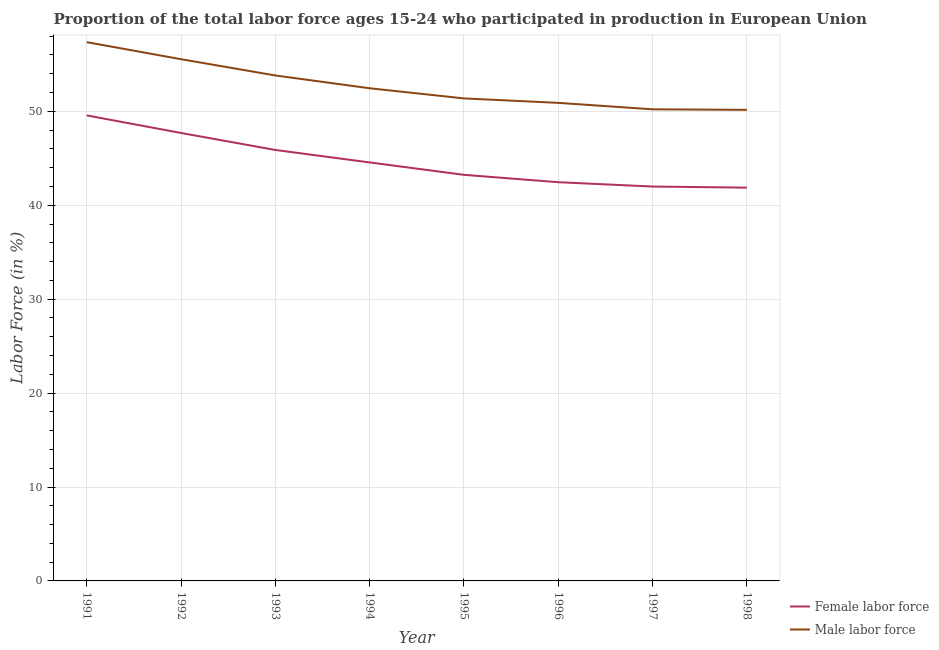How many different coloured lines are there?
Provide a succinct answer. 2. Is the number of lines equal to the number of legend labels?
Ensure brevity in your answer.  Yes. What is the percentage of female labor force in 1994?
Keep it short and to the point. 44.56. Across all years, what is the maximum percentage of female labor force?
Your answer should be compact. 49.57. Across all years, what is the minimum percentage of female labor force?
Give a very brief answer. 41.87. What is the total percentage of male labour force in the graph?
Offer a terse response. 421.84. What is the difference between the percentage of female labor force in 1992 and that in 1998?
Your answer should be compact. 5.82. What is the difference between the percentage of male labour force in 1996 and the percentage of female labor force in 1993?
Keep it short and to the point. 5.02. What is the average percentage of female labor force per year?
Keep it short and to the point. 44.66. In the year 1997, what is the difference between the percentage of female labor force and percentage of male labour force?
Keep it short and to the point. -8.22. In how many years, is the percentage of female labor force greater than 54 %?
Your answer should be very brief. 0. What is the ratio of the percentage of female labor force in 1993 to that in 1996?
Offer a terse response. 1.08. Is the difference between the percentage of female labor force in 1991 and 1993 greater than the difference between the percentage of male labour force in 1991 and 1993?
Ensure brevity in your answer.  Yes. What is the difference between the highest and the second highest percentage of female labor force?
Provide a short and direct response. 1.87. What is the difference between the highest and the lowest percentage of male labour force?
Offer a terse response. 7.21. In how many years, is the percentage of female labor force greater than the average percentage of female labor force taken over all years?
Your response must be concise. 3. Does the percentage of male labour force monotonically increase over the years?
Make the answer very short. No. Is the percentage of male labour force strictly greater than the percentage of female labor force over the years?
Your answer should be compact. Yes. Is the percentage of male labour force strictly less than the percentage of female labor force over the years?
Offer a terse response. No. How many lines are there?
Provide a succinct answer. 2. Are the values on the major ticks of Y-axis written in scientific E-notation?
Your answer should be compact. No. Where does the legend appear in the graph?
Your answer should be compact. Bottom right. How are the legend labels stacked?
Your response must be concise. Vertical. What is the title of the graph?
Ensure brevity in your answer.  Proportion of the total labor force ages 15-24 who participated in production in European Union. What is the Labor Force (in %) in Female labor force in 1991?
Ensure brevity in your answer.  49.57. What is the Labor Force (in %) in Male labor force in 1991?
Your answer should be compact. 57.37. What is the Labor Force (in %) of Female labor force in 1992?
Make the answer very short. 47.7. What is the Labor Force (in %) of Male labor force in 1992?
Provide a short and direct response. 55.55. What is the Labor Force (in %) of Female labor force in 1993?
Your answer should be very brief. 45.89. What is the Labor Force (in %) in Male labor force in 1993?
Offer a very short reply. 53.82. What is the Labor Force (in %) of Female labor force in 1994?
Your answer should be very brief. 44.56. What is the Labor Force (in %) in Male labor force in 1994?
Offer a very short reply. 52.46. What is the Labor Force (in %) of Female labor force in 1995?
Offer a terse response. 43.24. What is the Labor Force (in %) of Male labor force in 1995?
Provide a succinct answer. 51.38. What is the Labor Force (in %) of Female labor force in 1996?
Your answer should be very brief. 42.45. What is the Labor Force (in %) in Male labor force in 1996?
Make the answer very short. 50.9. What is the Labor Force (in %) in Female labor force in 1997?
Offer a terse response. 41.99. What is the Labor Force (in %) in Male labor force in 1997?
Your response must be concise. 50.21. What is the Labor Force (in %) of Female labor force in 1998?
Make the answer very short. 41.87. What is the Labor Force (in %) of Male labor force in 1998?
Your response must be concise. 50.16. Across all years, what is the maximum Labor Force (in %) in Female labor force?
Your response must be concise. 49.57. Across all years, what is the maximum Labor Force (in %) of Male labor force?
Give a very brief answer. 57.37. Across all years, what is the minimum Labor Force (in %) of Female labor force?
Provide a succinct answer. 41.87. Across all years, what is the minimum Labor Force (in %) of Male labor force?
Give a very brief answer. 50.16. What is the total Labor Force (in %) of Female labor force in the graph?
Your response must be concise. 357.26. What is the total Labor Force (in %) in Male labor force in the graph?
Your response must be concise. 421.84. What is the difference between the Labor Force (in %) in Female labor force in 1991 and that in 1992?
Your response must be concise. 1.87. What is the difference between the Labor Force (in %) of Male labor force in 1991 and that in 1992?
Provide a short and direct response. 1.82. What is the difference between the Labor Force (in %) in Female labor force in 1991 and that in 1993?
Your answer should be compact. 3.68. What is the difference between the Labor Force (in %) in Male labor force in 1991 and that in 1993?
Keep it short and to the point. 3.55. What is the difference between the Labor Force (in %) in Female labor force in 1991 and that in 1994?
Provide a succinct answer. 5.01. What is the difference between the Labor Force (in %) in Male labor force in 1991 and that in 1994?
Offer a terse response. 4.91. What is the difference between the Labor Force (in %) in Female labor force in 1991 and that in 1995?
Your answer should be compact. 6.33. What is the difference between the Labor Force (in %) of Male labor force in 1991 and that in 1995?
Provide a short and direct response. 5.99. What is the difference between the Labor Force (in %) of Female labor force in 1991 and that in 1996?
Your answer should be very brief. 7.11. What is the difference between the Labor Force (in %) in Male labor force in 1991 and that in 1996?
Provide a short and direct response. 6.46. What is the difference between the Labor Force (in %) in Female labor force in 1991 and that in 1997?
Your answer should be very brief. 7.58. What is the difference between the Labor Force (in %) of Male labor force in 1991 and that in 1997?
Offer a very short reply. 7.15. What is the difference between the Labor Force (in %) of Female labor force in 1991 and that in 1998?
Make the answer very short. 7.69. What is the difference between the Labor Force (in %) in Male labor force in 1991 and that in 1998?
Ensure brevity in your answer.  7.21. What is the difference between the Labor Force (in %) in Female labor force in 1992 and that in 1993?
Keep it short and to the point. 1.81. What is the difference between the Labor Force (in %) in Male labor force in 1992 and that in 1993?
Your response must be concise. 1.73. What is the difference between the Labor Force (in %) of Female labor force in 1992 and that in 1994?
Provide a succinct answer. 3.14. What is the difference between the Labor Force (in %) of Male labor force in 1992 and that in 1994?
Ensure brevity in your answer.  3.09. What is the difference between the Labor Force (in %) of Female labor force in 1992 and that in 1995?
Make the answer very short. 4.46. What is the difference between the Labor Force (in %) of Male labor force in 1992 and that in 1995?
Provide a succinct answer. 4.17. What is the difference between the Labor Force (in %) in Female labor force in 1992 and that in 1996?
Offer a very short reply. 5.24. What is the difference between the Labor Force (in %) of Male labor force in 1992 and that in 1996?
Your response must be concise. 4.65. What is the difference between the Labor Force (in %) of Female labor force in 1992 and that in 1997?
Your response must be concise. 5.71. What is the difference between the Labor Force (in %) in Male labor force in 1992 and that in 1997?
Provide a short and direct response. 5.34. What is the difference between the Labor Force (in %) of Female labor force in 1992 and that in 1998?
Provide a succinct answer. 5.82. What is the difference between the Labor Force (in %) in Male labor force in 1992 and that in 1998?
Your answer should be compact. 5.39. What is the difference between the Labor Force (in %) in Female labor force in 1993 and that in 1994?
Provide a succinct answer. 1.33. What is the difference between the Labor Force (in %) in Male labor force in 1993 and that in 1994?
Give a very brief answer. 1.36. What is the difference between the Labor Force (in %) of Female labor force in 1993 and that in 1995?
Your response must be concise. 2.65. What is the difference between the Labor Force (in %) of Male labor force in 1993 and that in 1995?
Ensure brevity in your answer.  2.44. What is the difference between the Labor Force (in %) in Female labor force in 1993 and that in 1996?
Provide a short and direct response. 3.43. What is the difference between the Labor Force (in %) in Male labor force in 1993 and that in 1996?
Provide a short and direct response. 2.92. What is the difference between the Labor Force (in %) in Female labor force in 1993 and that in 1997?
Your answer should be very brief. 3.9. What is the difference between the Labor Force (in %) of Male labor force in 1993 and that in 1997?
Offer a terse response. 3.6. What is the difference between the Labor Force (in %) of Female labor force in 1993 and that in 1998?
Offer a very short reply. 4.01. What is the difference between the Labor Force (in %) of Male labor force in 1993 and that in 1998?
Keep it short and to the point. 3.66. What is the difference between the Labor Force (in %) of Female labor force in 1994 and that in 1995?
Your response must be concise. 1.32. What is the difference between the Labor Force (in %) in Male labor force in 1994 and that in 1995?
Ensure brevity in your answer.  1.08. What is the difference between the Labor Force (in %) in Female labor force in 1994 and that in 1996?
Offer a terse response. 2.11. What is the difference between the Labor Force (in %) in Male labor force in 1994 and that in 1996?
Offer a terse response. 1.55. What is the difference between the Labor Force (in %) in Female labor force in 1994 and that in 1997?
Provide a succinct answer. 2.57. What is the difference between the Labor Force (in %) in Male labor force in 1994 and that in 1997?
Provide a short and direct response. 2.24. What is the difference between the Labor Force (in %) of Female labor force in 1994 and that in 1998?
Provide a succinct answer. 2.68. What is the difference between the Labor Force (in %) in Male labor force in 1994 and that in 1998?
Keep it short and to the point. 2.3. What is the difference between the Labor Force (in %) of Female labor force in 1995 and that in 1996?
Provide a succinct answer. 0.79. What is the difference between the Labor Force (in %) of Male labor force in 1995 and that in 1996?
Give a very brief answer. 0.47. What is the difference between the Labor Force (in %) in Female labor force in 1995 and that in 1997?
Give a very brief answer. 1.25. What is the difference between the Labor Force (in %) of Male labor force in 1995 and that in 1997?
Give a very brief answer. 1.16. What is the difference between the Labor Force (in %) of Female labor force in 1995 and that in 1998?
Make the answer very short. 1.36. What is the difference between the Labor Force (in %) of Male labor force in 1995 and that in 1998?
Make the answer very short. 1.22. What is the difference between the Labor Force (in %) in Female labor force in 1996 and that in 1997?
Make the answer very short. 0.46. What is the difference between the Labor Force (in %) in Male labor force in 1996 and that in 1997?
Ensure brevity in your answer.  0.69. What is the difference between the Labor Force (in %) in Female labor force in 1996 and that in 1998?
Provide a short and direct response. 0.58. What is the difference between the Labor Force (in %) of Male labor force in 1996 and that in 1998?
Ensure brevity in your answer.  0.74. What is the difference between the Labor Force (in %) of Female labor force in 1997 and that in 1998?
Provide a succinct answer. 0.12. What is the difference between the Labor Force (in %) of Male labor force in 1997 and that in 1998?
Make the answer very short. 0.06. What is the difference between the Labor Force (in %) of Female labor force in 1991 and the Labor Force (in %) of Male labor force in 1992?
Your response must be concise. -5.98. What is the difference between the Labor Force (in %) in Female labor force in 1991 and the Labor Force (in %) in Male labor force in 1993?
Your answer should be very brief. -4.25. What is the difference between the Labor Force (in %) in Female labor force in 1991 and the Labor Force (in %) in Male labor force in 1994?
Provide a succinct answer. -2.89. What is the difference between the Labor Force (in %) in Female labor force in 1991 and the Labor Force (in %) in Male labor force in 1995?
Keep it short and to the point. -1.81. What is the difference between the Labor Force (in %) in Female labor force in 1991 and the Labor Force (in %) in Male labor force in 1996?
Provide a succinct answer. -1.34. What is the difference between the Labor Force (in %) of Female labor force in 1991 and the Labor Force (in %) of Male labor force in 1997?
Offer a terse response. -0.65. What is the difference between the Labor Force (in %) in Female labor force in 1991 and the Labor Force (in %) in Male labor force in 1998?
Offer a terse response. -0.59. What is the difference between the Labor Force (in %) of Female labor force in 1992 and the Labor Force (in %) of Male labor force in 1993?
Ensure brevity in your answer.  -6.12. What is the difference between the Labor Force (in %) in Female labor force in 1992 and the Labor Force (in %) in Male labor force in 1994?
Keep it short and to the point. -4.76. What is the difference between the Labor Force (in %) of Female labor force in 1992 and the Labor Force (in %) of Male labor force in 1995?
Give a very brief answer. -3.68. What is the difference between the Labor Force (in %) in Female labor force in 1992 and the Labor Force (in %) in Male labor force in 1996?
Your response must be concise. -3.21. What is the difference between the Labor Force (in %) of Female labor force in 1992 and the Labor Force (in %) of Male labor force in 1997?
Your response must be concise. -2.52. What is the difference between the Labor Force (in %) in Female labor force in 1992 and the Labor Force (in %) in Male labor force in 1998?
Keep it short and to the point. -2.46. What is the difference between the Labor Force (in %) in Female labor force in 1993 and the Labor Force (in %) in Male labor force in 1994?
Offer a terse response. -6.57. What is the difference between the Labor Force (in %) in Female labor force in 1993 and the Labor Force (in %) in Male labor force in 1995?
Make the answer very short. -5.49. What is the difference between the Labor Force (in %) in Female labor force in 1993 and the Labor Force (in %) in Male labor force in 1996?
Your response must be concise. -5.02. What is the difference between the Labor Force (in %) of Female labor force in 1993 and the Labor Force (in %) of Male labor force in 1997?
Your response must be concise. -4.33. What is the difference between the Labor Force (in %) in Female labor force in 1993 and the Labor Force (in %) in Male labor force in 1998?
Your answer should be very brief. -4.27. What is the difference between the Labor Force (in %) in Female labor force in 1994 and the Labor Force (in %) in Male labor force in 1995?
Your response must be concise. -6.82. What is the difference between the Labor Force (in %) in Female labor force in 1994 and the Labor Force (in %) in Male labor force in 1996?
Ensure brevity in your answer.  -6.34. What is the difference between the Labor Force (in %) of Female labor force in 1994 and the Labor Force (in %) of Male labor force in 1997?
Your answer should be compact. -5.66. What is the difference between the Labor Force (in %) of Female labor force in 1994 and the Labor Force (in %) of Male labor force in 1998?
Keep it short and to the point. -5.6. What is the difference between the Labor Force (in %) of Female labor force in 1995 and the Labor Force (in %) of Male labor force in 1996?
Give a very brief answer. -7.66. What is the difference between the Labor Force (in %) of Female labor force in 1995 and the Labor Force (in %) of Male labor force in 1997?
Offer a terse response. -6.98. What is the difference between the Labor Force (in %) of Female labor force in 1995 and the Labor Force (in %) of Male labor force in 1998?
Offer a terse response. -6.92. What is the difference between the Labor Force (in %) of Female labor force in 1996 and the Labor Force (in %) of Male labor force in 1997?
Offer a very short reply. -7.76. What is the difference between the Labor Force (in %) of Female labor force in 1996 and the Labor Force (in %) of Male labor force in 1998?
Your answer should be compact. -7.7. What is the difference between the Labor Force (in %) of Female labor force in 1997 and the Labor Force (in %) of Male labor force in 1998?
Provide a short and direct response. -8.17. What is the average Labor Force (in %) in Female labor force per year?
Ensure brevity in your answer.  44.66. What is the average Labor Force (in %) of Male labor force per year?
Offer a terse response. 52.73. In the year 1991, what is the difference between the Labor Force (in %) of Female labor force and Labor Force (in %) of Male labor force?
Your answer should be compact. -7.8. In the year 1992, what is the difference between the Labor Force (in %) in Female labor force and Labor Force (in %) in Male labor force?
Offer a very short reply. -7.85. In the year 1993, what is the difference between the Labor Force (in %) in Female labor force and Labor Force (in %) in Male labor force?
Provide a succinct answer. -7.93. In the year 1994, what is the difference between the Labor Force (in %) of Female labor force and Labor Force (in %) of Male labor force?
Keep it short and to the point. -7.9. In the year 1995, what is the difference between the Labor Force (in %) in Female labor force and Labor Force (in %) in Male labor force?
Keep it short and to the point. -8.14. In the year 1996, what is the difference between the Labor Force (in %) in Female labor force and Labor Force (in %) in Male labor force?
Your answer should be very brief. -8.45. In the year 1997, what is the difference between the Labor Force (in %) of Female labor force and Labor Force (in %) of Male labor force?
Your response must be concise. -8.22. In the year 1998, what is the difference between the Labor Force (in %) of Female labor force and Labor Force (in %) of Male labor force?
Make the answer very short. -8.28. What is the ratio of the Labor Force (in %) in Female labor force in 1991 to that in 1992?
Make the answer very short. 1.04. What is the ratio of the Labor Force (in %) of Male labor force in 1991 to that in 1992?
Provide a short and direct response. 1.03. What is the ratio of the Labor Force (in %) of Female labor force in 1991 to that in 1993?
Give a very brief answer. 1.08. What is the ratio of the Labor Force (in %) of Male labor force in 1991 to that in 1993?
Your answer should be very brief. 1.07. What is the ratio of the Labor Force (in %) in Female labor force in 1991 to that in 1994?
Your answer should be compact. 1.11. What is the ratio of the Labor Force (in %) in Male labor force in 1991 to that in 1994?
Keep it short and to the point. 1.09. What is the ratio of the Labor Force (in %) of Female labor force in 1991 to that in 1995?
Your answer should be very brief. 1.15. What is the ratio of the Labor Force (in %) in Male labor force in 1991 to that in 1995?
Your response must be concise. 1.12. What is the ratio of the Labor Force (in %) in Female labor force in 1991 to that in 1996?
Give a very brief answer. 1.17. What is the ratio of the Labor Force (in %) of Male labor force in 1991 to that in 1996?
Offer a terse response. 1.13. What is the ratio of the Labor Force (in %) in Female labor force in 1991 to that in 1997?
Ensure brevity in your answer.  1.18. What is the ratio of the Labor Force (in %) in Male labor force in 1991 to that in 1997?
Offer a terse response. 1.14. What is the ratio of the Labor Force (in %) of Female labor force in 1991 to that in 1998?
Offer a terse response. 1.18. What is the ratio of the Labor Force (in %) of Male labor force in 1991 to that in 1998?
Make the answer very short. 1.14. What is the ratio of the Labor Force (in %) of Female labor force in 1992 to that in 1993?
Ensure brevity in your answer.  1.04. What is the ratio of the Labor Force (in %) in Male labor force in 1992 to that in 1993?
Your answer should be very brief. 1.03. What is the ratio of the Labor Force (in %) of Female labor force in 1992 to that in 1994?
Your response must be concise. 1.07. What is the ratio of the Labor Force (in %) in Male labor force in 1992 to that in 1994?
Make the answer very short. 1.06. What is the ratio of the Labor Force (in %) of Female labor force in 1992 to that in 1995?
Keep it short and to the point. 1.1. What is the ratio of the Labor Force (in %) in Male labor force in 1992 to that in 1995?
Your response must be concise. 1.08. What is the ratio of the Labor Force (in %) in Female labor force in 1992 to that in 1996?
Give a very brief answer. 1.12. What is the ratio of the Labor Force (in %) of Male labor force in 1992 to that in 1996?
Make the answer very short. 1.09. What is the ratio of the Labor Force (in %) in Female labor force in 1992 to that in 1997?
Provide a succinct answer. 1.14. What is the ratio of the Labor Force (in %) in Male labor force in 1992 to that in 1997?
Make the answer very short. 1.11. What is the ratio of the Labor Force (in %) of Female labor force in 1992 to that in 1998?
Offer a terse response. 1.14. What is the ratio of the Labor Force (in %) of Male labor force in 1992 to that in 1998?
Offer a very short reply. 1.11. What is the ratio of the Labor Force (in %) of Female labor force in 1993 to that in 1994?
Provide a short and direct response. 1.03. What is the ratio of the Labor Force (in %) in Female labor force in 1993 to that in 1995?
Make the answer very short. 1.06. What is the ratio of the Labor Force (in %) in Male labor force in 1993 to that in 1995?
Offer a very short reply. 1.05. What is the ratio of the Labor Force (in %) in Female labor force in 1993 to that in 1996?
Your answer should be very brief. 1.08. What is the ratio of the Labor Force (in %) in Male labor force in 1993 to that in 1996?
Your response must be concise. 1.06. What is the ratio of the Labor Force (in %) in Female labor force in 1993 to that in 1997?
Ensure brevity in your answer.  1.09. What is the ratio of the Labor Force (in %) in Male labor force in 1993 to that in 1997?
Offer a terse response. 1.07. What is the ratio of the Labor Force (in %) of Female labor force in 1993 to that in 1998?
Offer a terse response. 1.1. What is the ratio of the Labor Force (in %) in Male labor force in 1993 to that in 1998?
Your response must be concise. 1.07. What is the ratio of the Labor Force (in %) of Female labor force in 1994 to that in 1995?
Your answer should be compact. 1.03. What is the ratio of the Labor Force (in %) in Male labor force in 1994 to that in 1995?
Offer a very short reply. 1.02. What is the ratio of the Labor Force (in %) in Female labor force in 1994 to that in 1996?
Provide a short and direct response. 1.05. What is the ratio of the Labor Force (in %) of Male labor force in 1994 to that in 1996?
Provide a succinct answer. 1.03. What is the ratio of the Labor Force (in %) of Female labor force in 1994 to that in 1997?
Keep it short and to the point. 1.06. What is the ratio of the Labor Force (in %) in Male labor force in 1994 to that in 1997?
Offer a terse response. 1.04. What is the ratio of the Labor Force (in %) of Female labor force in 1994 to that in 1998?
Provide a short and direct response. 1.06. What is the ratio of the Labor Force (in %) of Male labor force in 1994 to that in 1998?
Offer a very short reply. 1.05. What is the ratio of the Labor Force (in %) of Female labor force in 1995 to that in 1996?
Give a very brief answer. 1.02. What is the ratio of the Labor Force (in %) of Male labor force in 1995 to that in 1996?
Provide a short and direct response. 1.01. What is the ratio of the Labor Force (in %) of Female labor force in 1995 to that in 1997?
Offer a very short reply. 1.03. What is the ratio of the Labor Force (in %) in Male labor force in 1995 to that in 1997?
Your answer should be compact. 1.02. What is the ratio of the Labor Force (in %) in Female labor force in 1995 to that in 1998?
Provide a short and direct response. 1.03. What is the ratio of the Labor Force (in %) in Male labor force in 1995 to that in 1998?
Keep it short and to the point. 1.02. What is the ratio of the Labor Force (in %) in Female labor force in 1996 to that in 1997?
Your answer should be very brief. 1.01. What is the ratio of the Labor Force (in %) of Male labor force in 1996 to that in 1997?
Your answer should be very brief. 1.01. What is the ratio of the Labor Force (in %) in Female labor force in 1996 to that in 1998?
Offer a very short reply. 1.01. What is the ratio of the Labor Force (in %) of Male labor force in 1996 to that in 1998?
Keep it short and to the point. 1.01. What is the ratio of the Labor Force (in %) in Female labor force in 1997 to that in 1998?
Your response must be concise. 1. What is the ratio of the Labor Force (in %) of Male labor force in 1997 to that in 1998?
Make the answer very short. 1. What is the difference between the highest and the second highest Labor Force (in %) of Female labor force?
Your answer should be very brief. 1.87. What is the difference between the highest and the second highest Labor Force (in %) in Male labor force?
Give a very brief answer. 1.82. What is the difference between the highest and the lowest Labor Force (in %) in Female labor force?
Make the answer very short. 7.69. What is the difference between the highest and the lowest Labor Force (in %) of Male labor force?
Offer a very short reply. 7.21. 